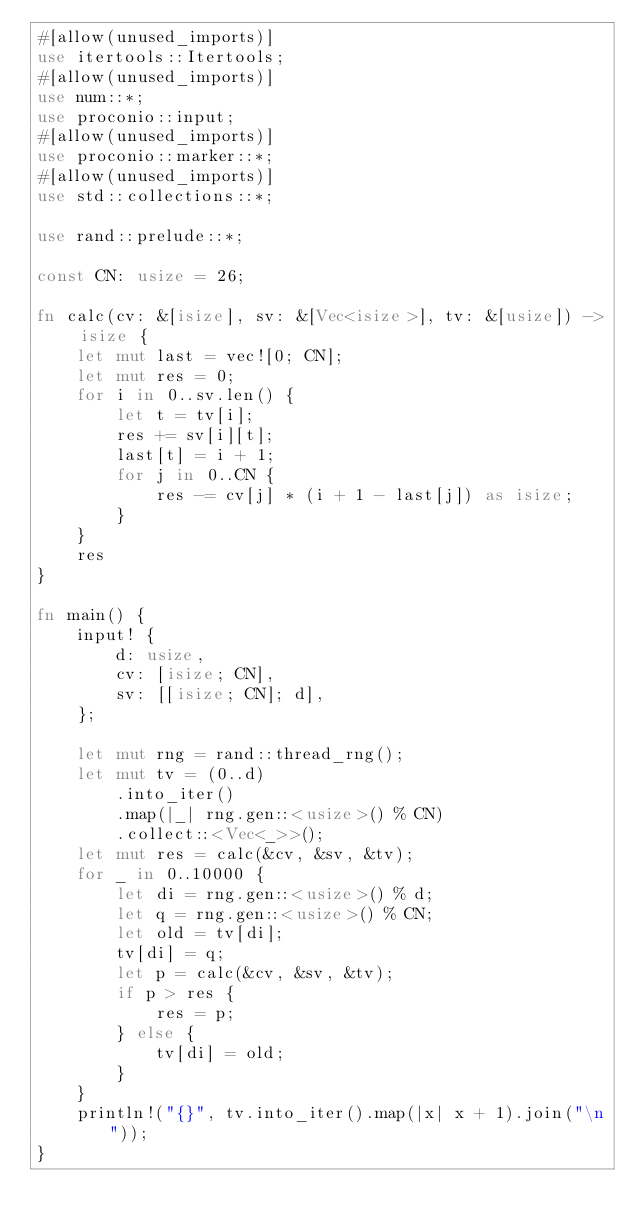Convert code to text. <code><loc_0><loc_0><loc_500><loc_500><_Rust_>#[allow(unused_imports)]
use itertools::Itertools;
#[allow(unused_imports)]
use num::*;
use proconio::input;
#[allow(unused_imports)]
use proconio::marker::*;
#[allow(unused_imports)]
use std::collections::*;

use rand::prelude::*;

const CN: usize = 26;

fn calc(cv: &[isize], sv: &[Vec<isize>], tv: &[usize]) -> isize {
    let mut last = vec![0; CN];
    let mut res = 0;
    for i in 0..sv.len() {
        let t = tv[i];
        res += sv[i][t];
        last[t] = i + 1;
        for j in 0..CN {
            res -= cv[j] * (i + 1 - last[j]) as isize;
        }
    }
    res
}

fn main() {
    input! {
        d: usize,
        cv: [isize; CN],
        sv: [[isize; CN]; d],
    };

    let mut rng = rand::thread_rng();
    let mut tv = (0..d)
        .into_iter()
        .map(|_| rng.gen::<usize>() % CN)
        .collect::<Vec<_>>();
    let mut res = calc(&cv, &sv, &tv);
    for _ in 0..10000 {
        let di = rng.gen::<usize>() % d;
        let q = rng.gen::<usize>() % CN;
        let old = tv[di];
        tv[di] = q;
        let p = calc(&cv, &sv, &tv);
        if p > res {
            res = p;
        } else {
            tv[di] = old;
        }
    }
    println!("{}", tv.into_iter().map(|x| x + 1).join("\n"));
}
</code> 